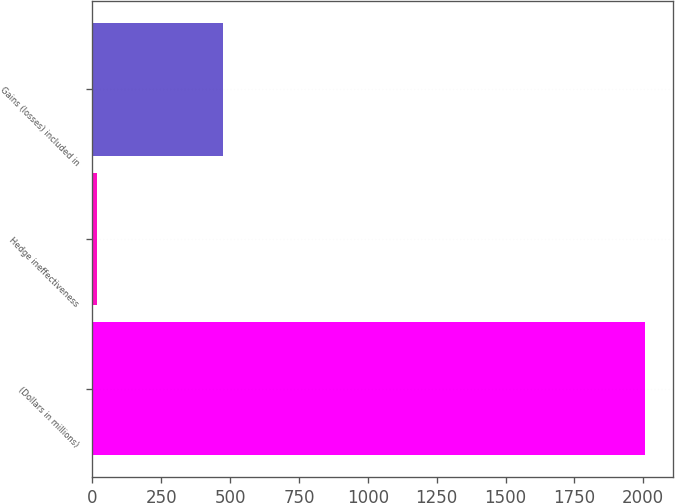<chart> <loc_0><loc_0><loc_500><loc_500><bar_chart><fcel>(Dollars in millions)<fcel>Hedge ineffectiveness<fcel>Gains (losses) included in<nl><fcel>2006<fcel>18<fcel>475<nl></chart> 